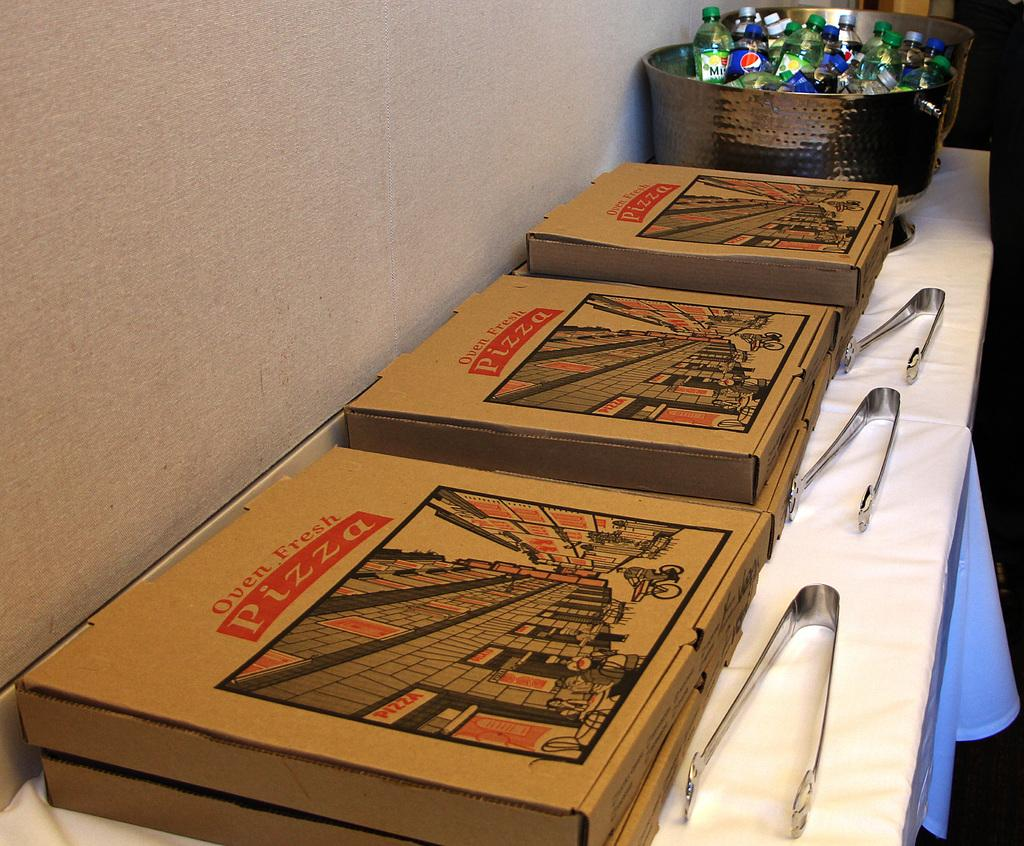<image>
Present a compact description of the photo's key features. Several pizza boxes say that the pizza is "oven fresh". 